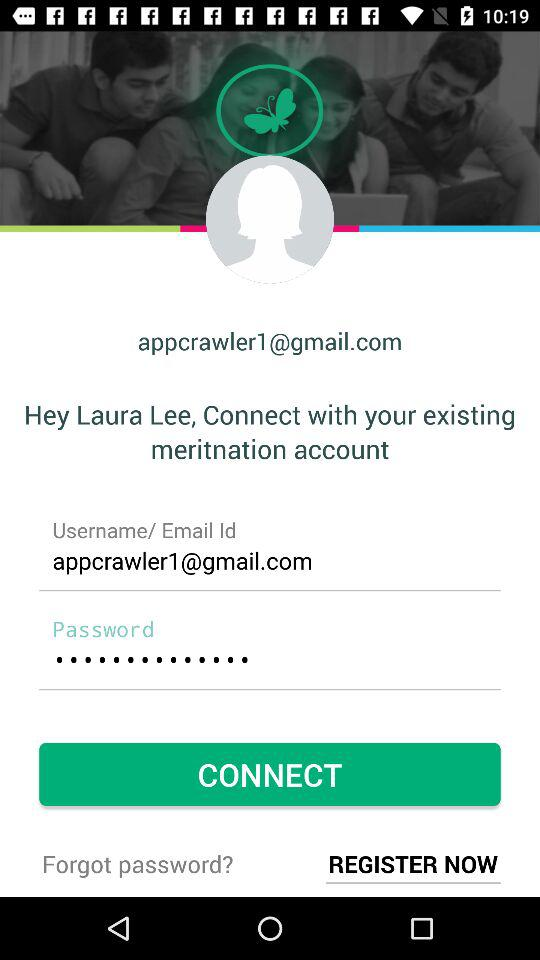What is the Gmail account address? The Gmail account address is appcrawler1@gmail.com. 